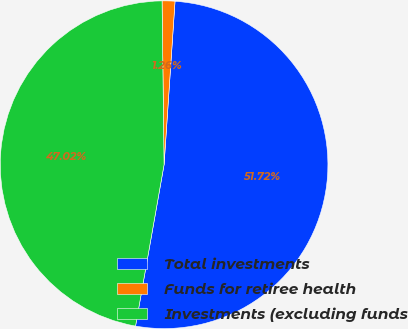<chart> <loc_0><loc_0><loc_500><loc_500><pie_chart><fcel>Total investments<fcel>Funds for retiree health<fcel>Investments (excluding funds<nl><fcel>51.72%<fcel>1.26%<fcel>47.02%<nl></chart> 